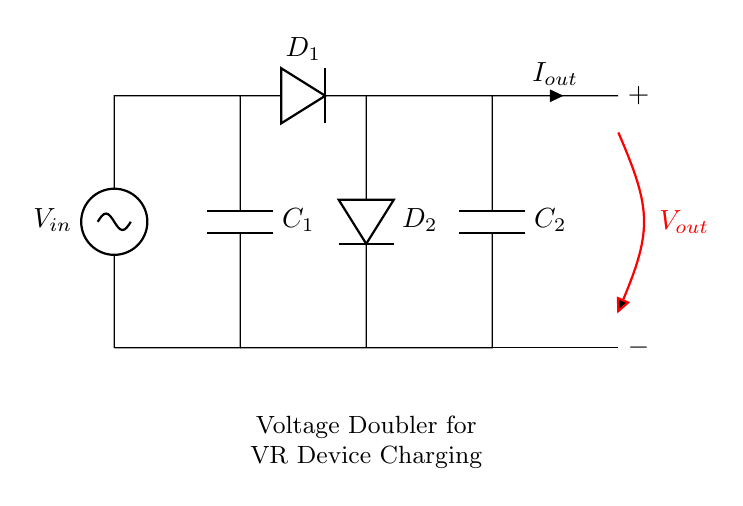What type of circuit is this? This circuit is a voltage doubler rectifier, which is designed to increase the input voltage to a higher output voltage using capacitors and diodes.
Answer: voltage doubler rectifier How many diodes are present in this circuit? There are two diodes present, labeled D1 and D2, which are used to rectify the AC voltage into DC voltage in the circuit.
Answer: 2 What is the role of capacitor C1? Capacitor C1 serves to charge during the positive half of the input voltage cycle, storing energy that is then used for doubling the voltage output when D1 conducts.
Answer: Energy storage What is the purpose of this circuit? The circuit is used for charging portable VR devices, as it doubles the input voltage to provide sufficient power for efficient charging during remote training sessions.
Answer: Charging VR devices What is the direction of current flow indicated by Iout? The current flow indicated by Iout is directed from the output node towards the load that represents the VR device, providing the required power for operation.
Answer: To the load What is the output voltage relative to the input voltage? The output voltage is approximately double the input voltage, as indicated by the circuit's design and function to double the voltage using capacitors and diodes.
Answer: Double the input voltage What happens to capacitor C2 after it is charged? After capacitor C2 is charged, it holds the increased voltage for output, providing a smooth and stable DC voltage for the load.
Answer: Holds increased voltage 